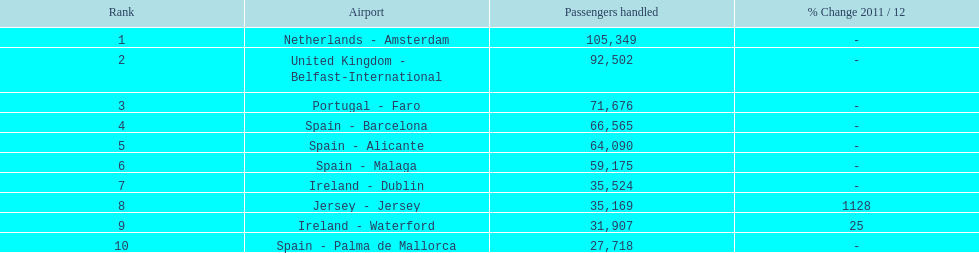How many passengers are going to or coming from spain? 217,548. 